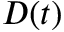Convert formula to latex. <formula><loc_0><loc_0><loc_500><loc_500>D ( t )</formula> 